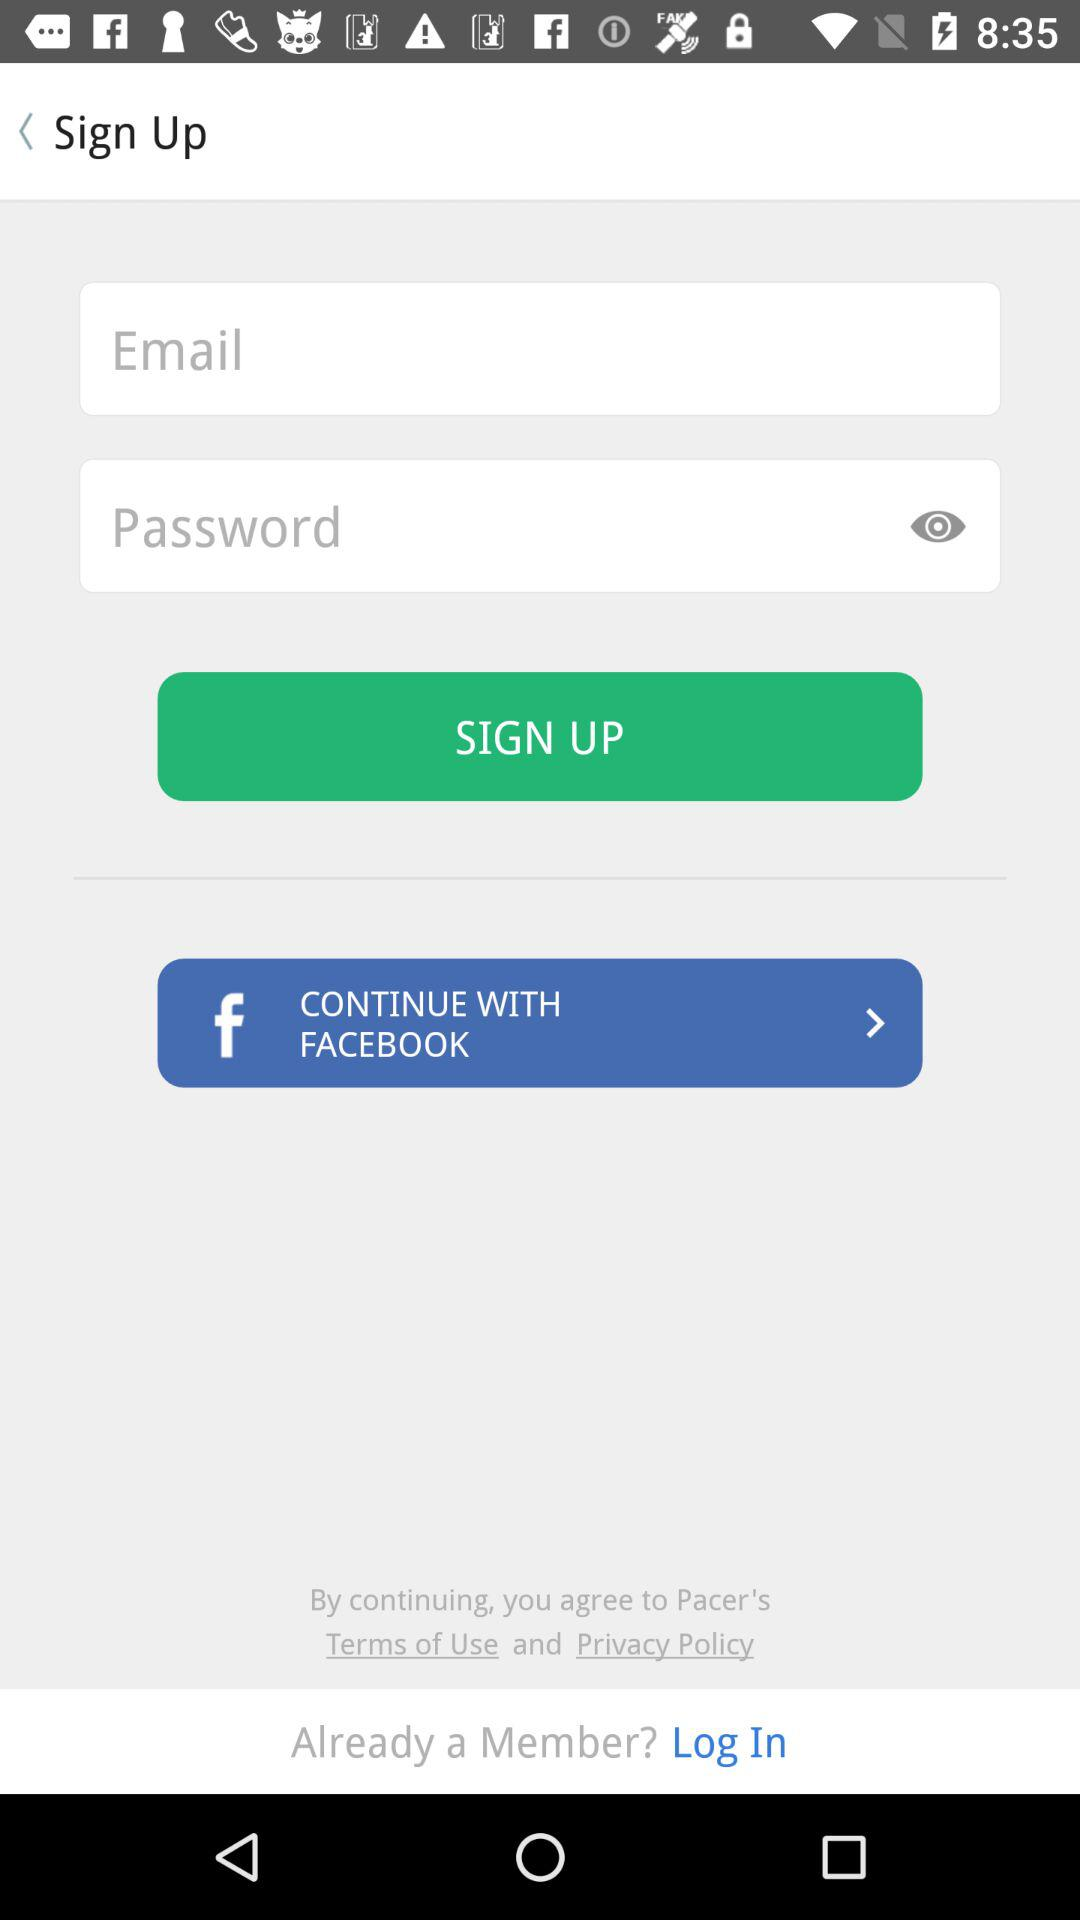Through what application can we continue? You can continue through "FACEBOOK". 